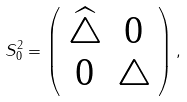Convert formula to latex. <formula><loc_0><loc_0><loc_500><loc_500>S _ { 0 } ^ { 2 } = \left ( \begin{array} { c c } \widehat { \triangle } & 0 \\ 0 & \triangle \end{array} \right ) ,</formula> 